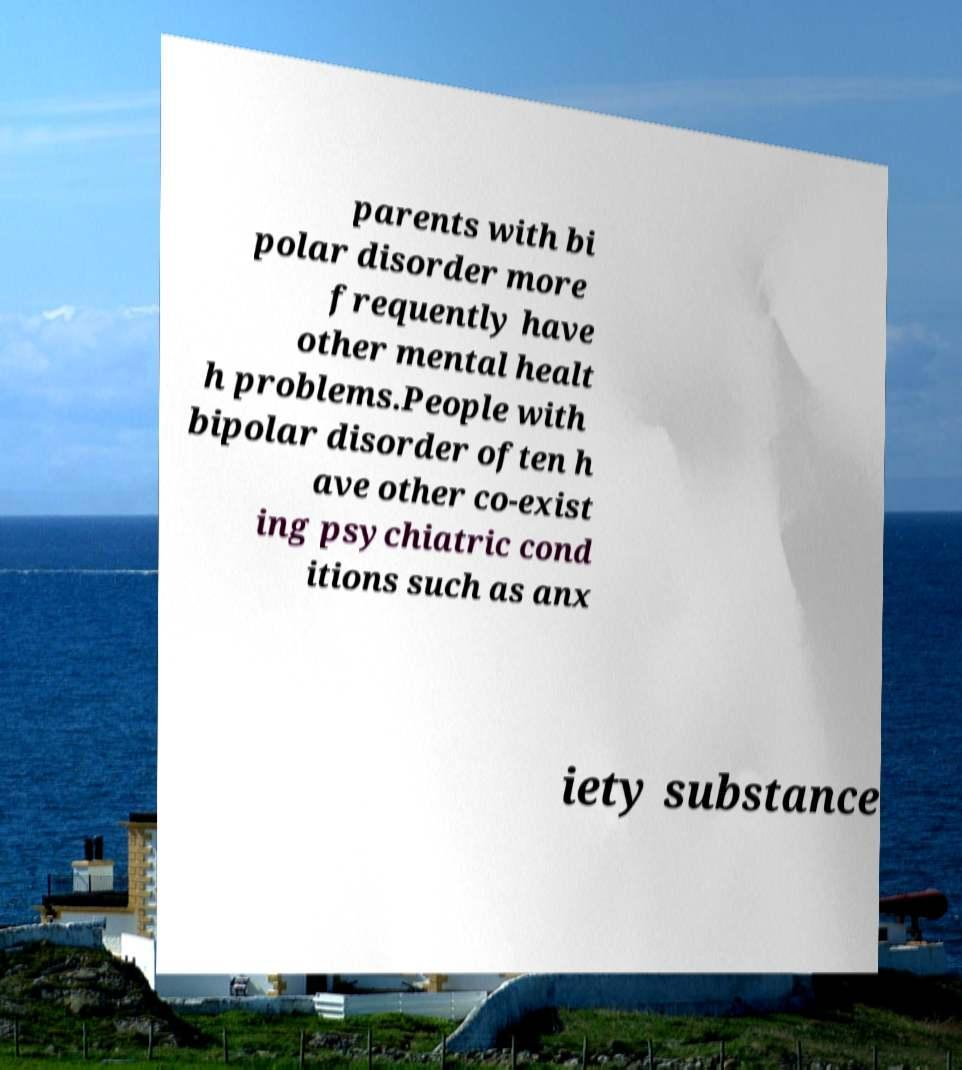Can you accurately transcribe the text from the provided image for me? parents with bi polar disorder more frequently have other mental healt h problems.People with bipolar disorder often h ave other co-exist ing psychiatric cond itions such as anx iety substance 